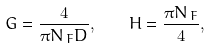<formula> <loc_0><loc_0><loc_500><loc_500>G = \frac { 4 } { \pi N _ { \, F } D } , \quad H = \frac { \pi N _ { \, F } } { 4 } ,</formula> 